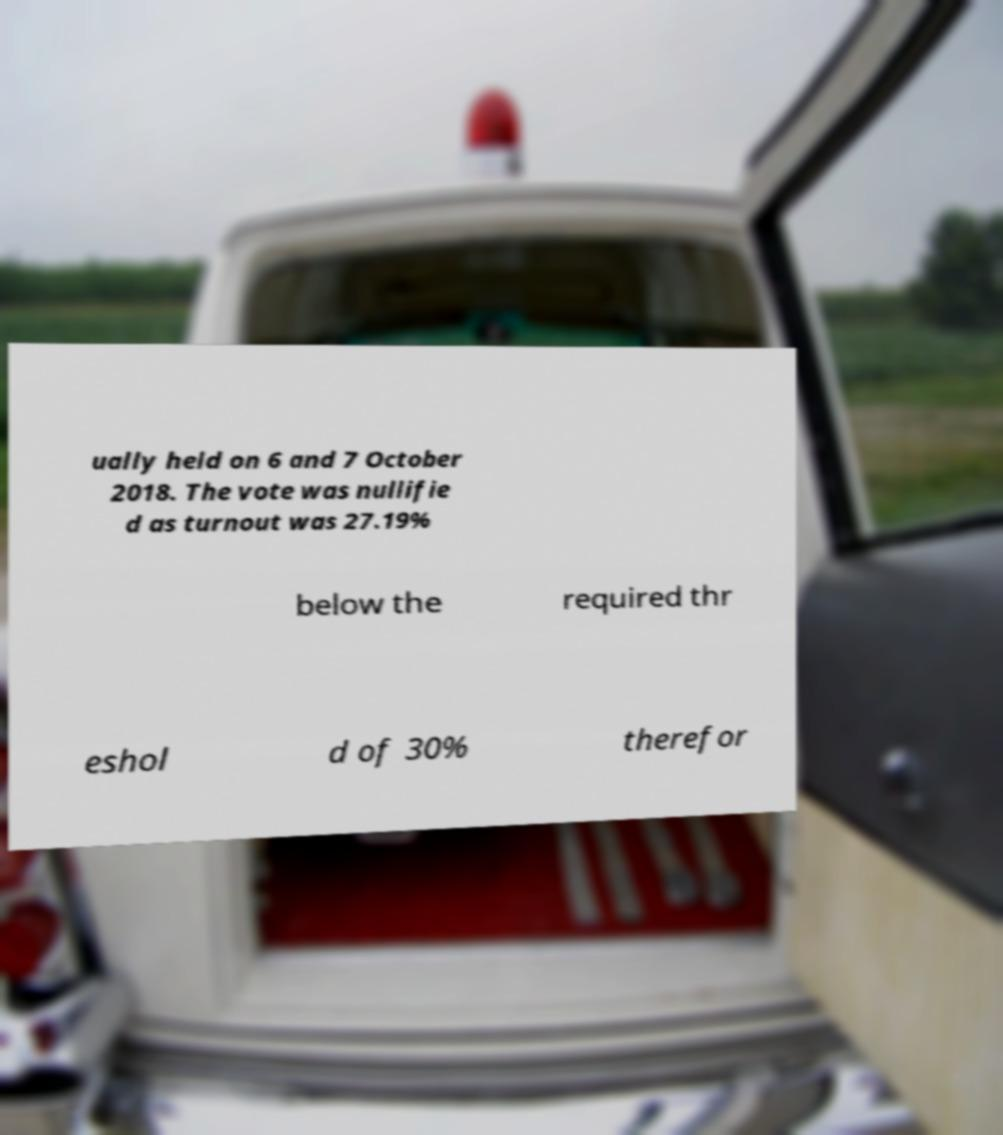There's text embedded in this image that I need extracted. Can you transcribe it verbatim? ually held on 6 and 7 October 2018. The vote was nullifie d as turnout was 27.19% below the required thr eshol d of 30% therefor 